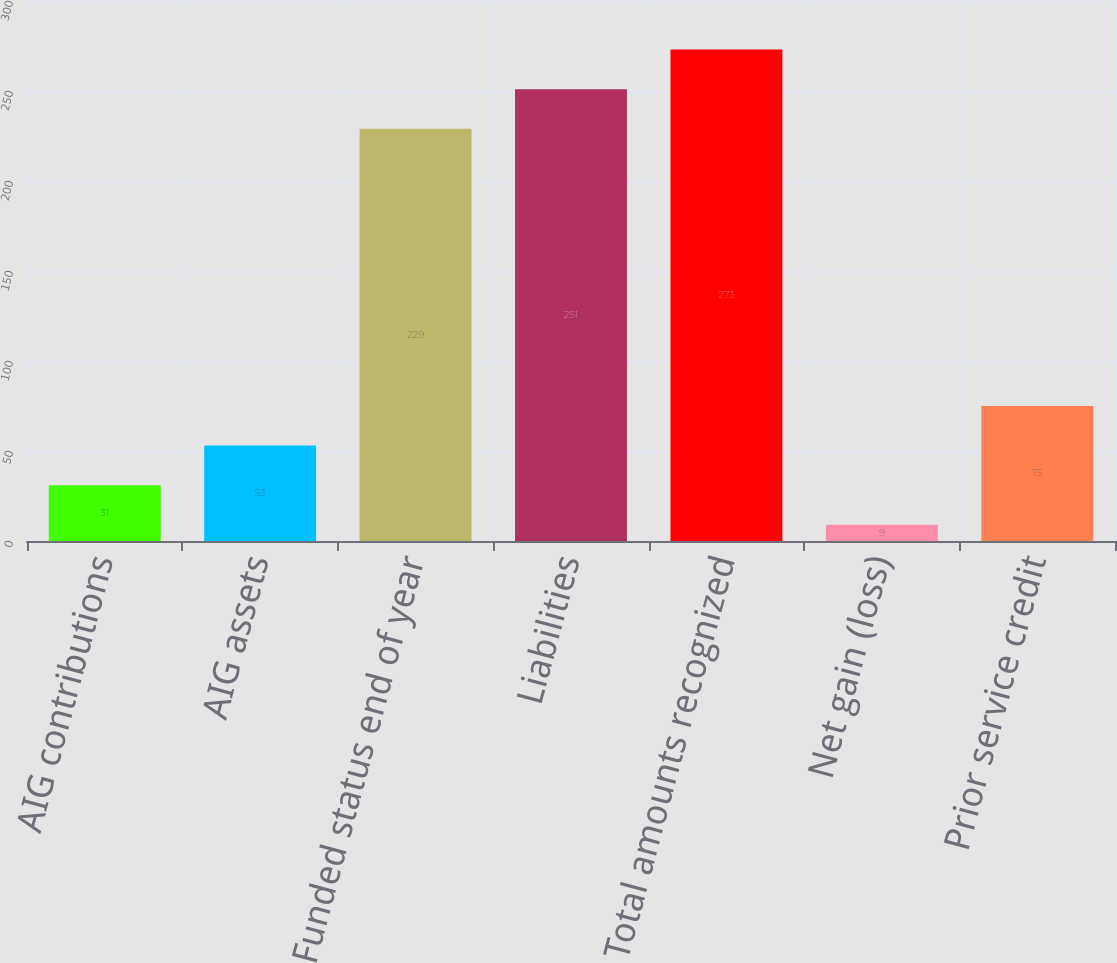<chart> <loc_0><loc_0><loc_500><loc_500><bar_chart><fcel>AIG contributions<fcel>AIG assets<fcel>Funded status end of year<fcel>Liabilities<fcel>Total amounts recognized<fcel>Net gain (loss)<fcel>Prior service credit<nl><fcel>31<fcel>53<fcel>229<fcel>251<fcel>273<fcel>9<fcel>75<nl></chart> 